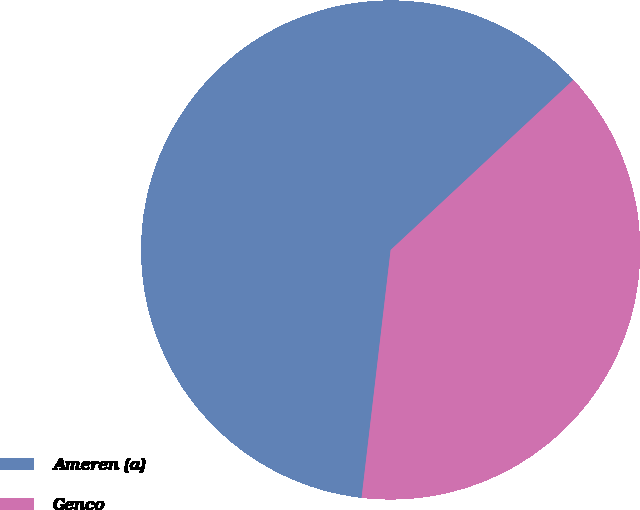Convert chart to OTSL. <chart><loc_0><loc_0><loc_500><loc_500><pie_chart><fcel>Ameren (a)<fcel>Genco<nl><fcel>61.21%<fcel>38.79%<nl></chart> 